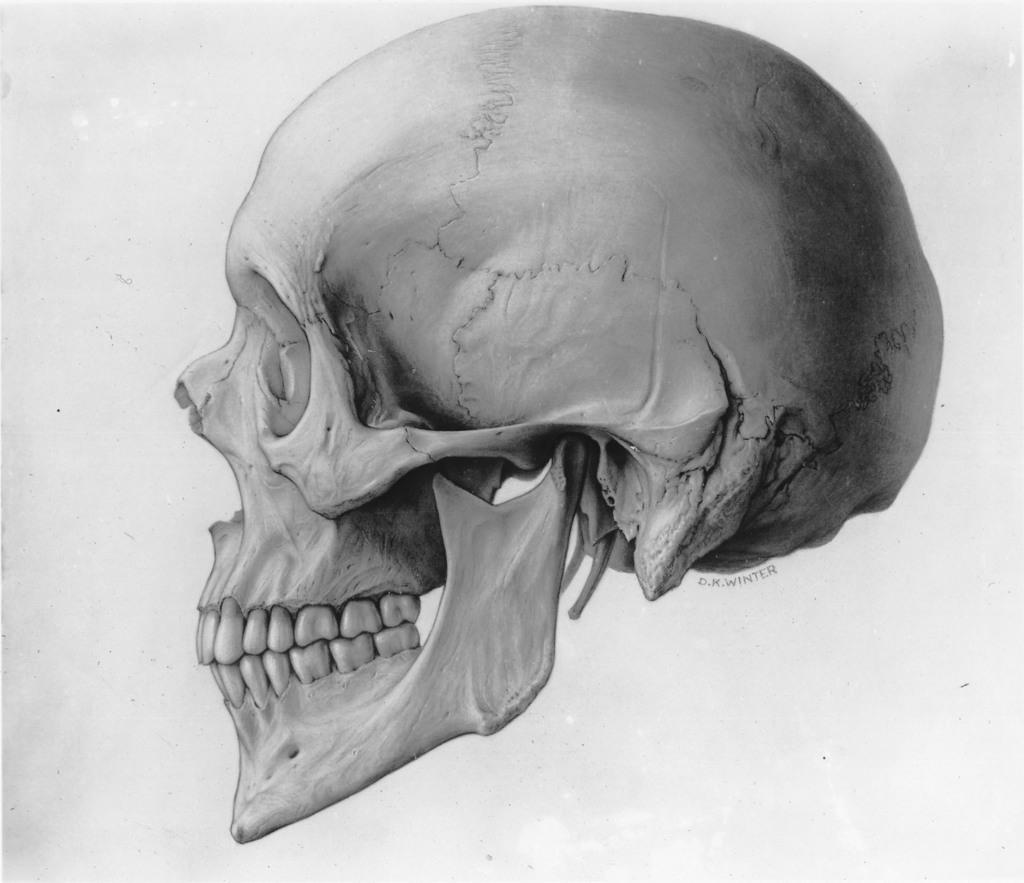Please provide a concise description of this image. In this image we can see a skull. 